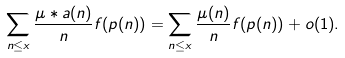<formula> <loc_0><loc_0><loc_500><loc_500>\sum _ { n \leq x } \frac { \mu * a ( n ) } { n } f ( p ( n ) ) = \sum _ { n \leq x } \frac { \mu ( n ) } { n } f ( p ( n ) ) + o ( 1 ) .</formula> 